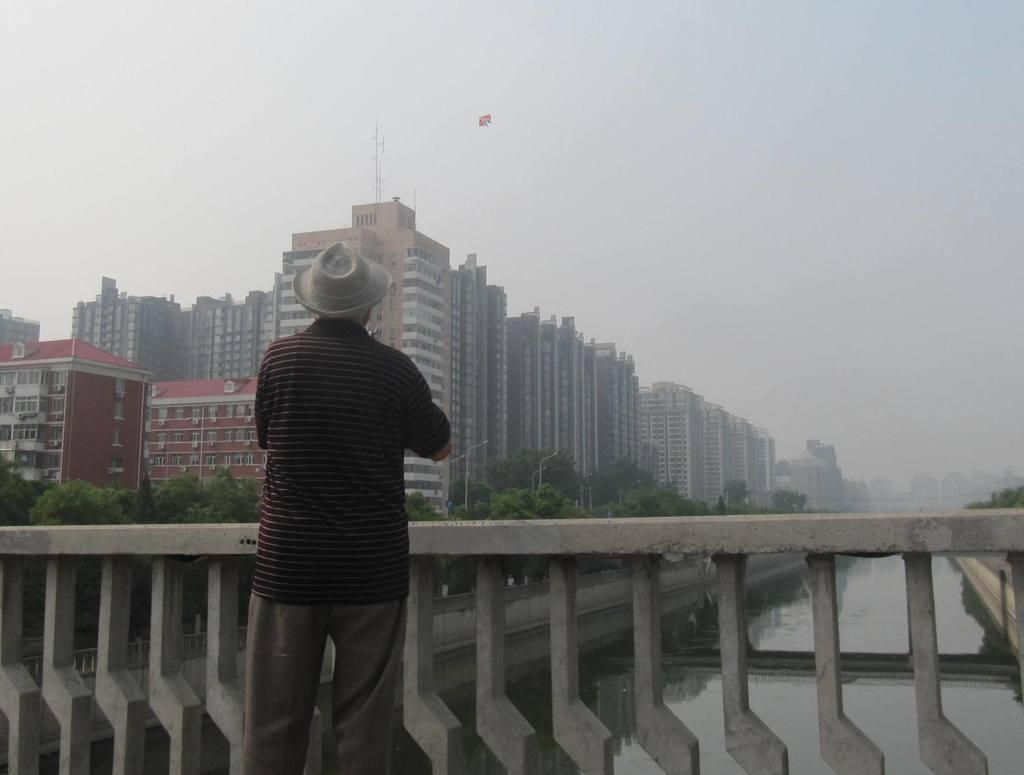What is the person in the image doing? The person is standing on a bridge in the image. What can be seen below the bridge? There is water visible in the image. What type of structures are present in the image? There are buildings in the image. What type of vegetation is present in the image? Trees are present in the image. What type of vertical structures are visible in the image? Poles are visible in the image. What type of illumination is present in the image? Lights are present in the image. What is visible in the background of the image? The sky is visible in the background of the image. What type of maid is visible in the image? There is no maid present in the image. 